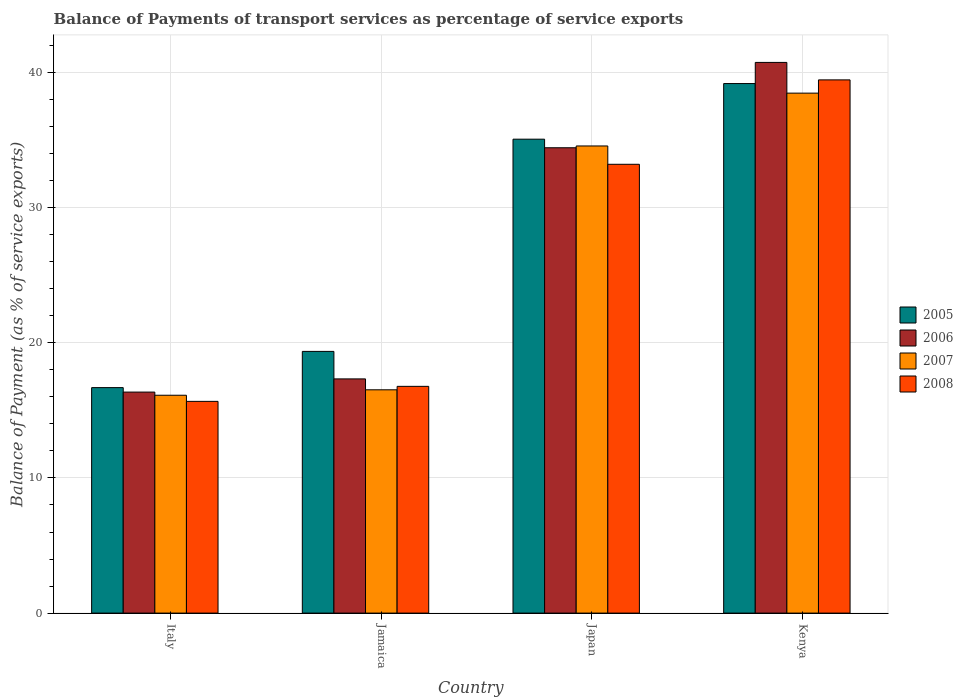How many different coloured bars are there?
Give a very brief answer. 4. Are the number of bars per tick equal to the number of legend labels?
Give a very brief answer. Yes. Are the number of bars on each tick of the X-axis equal?
Your answer should be compact. Yes. How many bars are there on the 2nd tick from the right?
Your answer should be compact. 4. What is the label of the 1st group of bars from the left?
Offer a very short reply. Italy. What is the balance of payments of transport services in 2008 in Kenya?
Provide a succinct answer. 39.45. Across all countries, what is the maximum balance of payments of transport services in 2006?
Offer a terse response. 40.74. Across all countries, what is the minimum balance of payments of transport services in 2006?
Offer a terse response. 16.35. In which country was the balance of payments of transport services in 2007 maximum?
Keep it short and to the point. Kenya. What is the total balance of payments of transport services in 2008 in the graph?
Give a very brief answer. 105.1. What is the difference between the balance of payments of transport services in 2005 in Jamaica and that in Kenya?
Your answer should be very brief. -19.82. What is the difference between the balance of payments of transport services in 2008 in Japan and the balance of payments of transport services in 2006 in Kenya?
Give a very brief answer. -7.54. What is the average balance of payments of transport services in 2005 per country?
Your response must be concise. 27.57. What is the difference between the balance of payments of transport services of/in 2006 and balance of payments of transport services of/in 2007 in Italy?
Offer a terse response. 0.23. What is the ratio of the balance of payments of transport services in 2006 in Italy to that in Jamaica?
Make the answer very short. 0.94. What is the difference between the highest and the second highest balance of payments of transport services in 2005?
Give a very brief answer. -15.7. What is the difference between the highest and the lowest balance of payments of transport services in 2005?
Your answer should be very brief. 22.5. In how many countries, is the balance of payments of transport services in 2008 greater than the average balance of payments of transport services in 2008 taken over all countries?
Keep it short and to the point. 2. Is the sum of the balance of payments of transport services in 2006 in Italy and Jamaica greater than the maximum balance of payments of transport services in 2007 across all countries?
Your response must be concise. No. What does the 4th bar from the right in Jamaica represents?
Make the answer very short. 2005. How many bars are there?
Make the answer very short. 16. Does the graph contain any zero values?
Offer a terse response. No. Does the graph contain grids?
Your response must be concise. Yes. Where does the legend appear in the graph?
Give a very brief answer. Center right. How many legend labels are there?
Make the answer very short. 4. What is the title of the graph?
Offer a very short reply. Balance of Payments of transport services as percentage of service exports. What is the label or title of the Y-axis?
Your answer should be very brief. Balance of Payment (as % of service exports). What is the Balance of Payment (as % of service exports) in 2005 in Italy?
Provide a short and direct response. 16.68. What is the Balance of Payment (as % of service exports) in 2006 in Italy?
Your answer should be compact. 16.35. What is the Balance of Payment (as % of service exports) of 2007 in Italy?
Your answer should be compact. 16.12. What is the Balance of Payment (as % of service exports) in 2008 in Italy?
Provide a succinct answer. 15.67. What is the Balance of Payment (as % of service exports) of 2005 in Jamaica?
Ensure brevity in your answer.  19.36. What is the Balance of Payment (as % of service exports) of 2006 in Jamaica?
Provide a succinct answer. 17.33. What is the Balance of Payment (as % of service exports) of 2007 in Jamaica?
Ensure brevity in your answer.  16.52. What is the Balance of Payment (as % of service exports) of 2008 in Jamaica?
Your response must be concise. 16.78. What is the Balance of Payment (as % of service exports) in 2005 in Japan?
Ensure brevity in your answer.  35.06. What is the Balance of Payment (as % of service exports) of 2006 in Japan?
Make the answer very short. 34.43. What is the Balance of Payment (as % of service exports) in 2007 in Japan?
Provide a short and direct response. 34.56. What is the Balance of Payment (as % of service exports) in 2008 in Japan?
Provide a short and direct response. 33.21. What is the Balance of Payment (as % of service exports) in 2005 in Kenya?
Offer a terse response. 39.18. What is the Balance of Payment (as % of service exports) of 2006 in Kenya?
Your answer should be very brief. 40.74. What is the Balance of Payment (as % of service exports) in 2007 in Kenya?
Provide a short and direct response. 38.47. What is the Balance of Payment (as % of service exports) of 2008 in Kenya?
Make the answer very short. 39.45. Across all countries, what is the maximum Balance of Payment (as % of service exports) of 2005?
Your response must be concise. 39.18. Across all countries, what is the maximum Balance of Payment (as % of service exports) of 2006?
Give a very brief answer. 40.74. Across all countries, what is the maximum Balance of Payment (as % of service exports) of 2007?
Provide a succinct answer. 38.47. Across all countries, what is the maximum Balance of Payment (as % of service exports) of 2008?
Give a very brief answer. 39.45. Across all countries, what is the minimum Balance of Payment (as % of service exports) in 2005?
Ensure brevity in your answer.  16.68. Across all countries, what is the minimum Balance of Payment (as % of service exports) in 2006?
Keep it short and to the point. 16.35. Across all countries, what is the minimum Balance of Payment (as % of service exports) of 2007?
Provide a short and direct response. 16.12. Across all countries, what is the minimum Balance of Payment (as % of service exports) of 2008?
Your answer should be very brief. 15.67. What is the total Balance of Payment (as % of service exports) of 2005 in the graph?
Ensure brevity in your answer.  110.29. What is the total Balance of Payment (as % of service exports) of 2006 in the graph?
Ensure brevity in your answer.  108.85. What is the total Balance of Payment (as % of service exports) in 2007 in the graph?
Keep it short and to the point. 105.67. What is the total Balance of Payment (as % of service exports) in 2008 in the graph?
Keep it short and to the point. 105.1. What is the difference between the Balance of Payment (as % of service exports) in 2005 in Italy and that in Jamaica?
Your answer should be compact. -2.68. What is the difference between the Balance of Payment (as % of service exports) in 2006 in Italy and that in Jamaica?
Your answer should be very brief. -0.98. What is the difference between the Balance of Payment (as % of service exports) of 2007 in Italy and that in Jamaica?
Give a very brief answer. -0.4. What is the difference between the Balance of Payment (as % of service exports) of 2008 in Italy and that in Jamaica?
Provide a short and direct response. -1.11. What is the difference between the Balance of Payment (as % of service exports) of 2005 in Italy and that in Japan?
Your answer should be compact. -18.38. What is the difference between the Balance of Payment (as % of service exports) in 2006 in Italy and that in Japan?
Offer a very short reply. -18.08. What is the difference between the Balance of Payment (as % of service exports) of 2007 in Italy and that in Japan?
Give a very brief answer. -18.44. What is the difference between the Balance of Payment (as % of service exports) of 2008 in Italy and that in Japan?
Your answer should be very brief. -17.54. What is the difference between the Balance of Payment (as % of service exports) in 2005 in Italy and that in Kenya?
Keep it short and to the point. -22.5. What is the difference between the Balance of Payment (as % of service exports) in 2006 in Italy and that in Kenya?
Keep it short and to the point. -24.39. What is the difference between the Balance of Payment (as % of service exports) of 2007 in Italy and that in Kenya?
Make the answer very short. -22.35. What is the difference between the Balance of Payment (as % of service exports) of 2008 in Italy and that in Kenya?
Your response must be concise. -23.79. What is the difference between the Balance of Payment (as % of service exports) of 2005 in Jamaica and that in Japan?
Make the answer very short. -15.7. What is the difference between the Balance of Payment (as % of service exports) of 2006 in Jamaica and that in Japan?
Your answer should be compact. -17.1. What is the difference between the Balance of Payment (as % of service exports) of 2007 in Jamaica and that in Japan?
Give a very brief answer. -18.04. What is the difference between the Balance of Payment (as % of service exports) in 2008 in Jamaica and that in Japan?
Your answer should be compact. -16.43. What is the difference between the Balance of Payment (as % of service exports) in 2005 in Jamaica and that in Kenya?
Ensure brevity in your answer.  -19.82. What is the difference between the Balance of Payment (as % of service exports) in 2006 in Jamaica and that in Kenya?
Make the answer very short. -23.42. What is the difference between the Balance of Payment (as % of service exports) in 2007 in Jamaica and that in Kenya?
Offer a very short reply. -21.95. What is the difference between the Balance of Payment (as % of service exports) of 2008 in Jamaica and that in Kenya?
Keep it short and to the point. -22.67. What is the difference between the Balance of Payment (as % of service exports) of 2005 in Japan and that in Kenya?
Your answer should be compact. -4.12. What is the difference between the Balance of Payment (as % of service exports) of 2006 in Japan and that in Kenya?
Ensure brevity in your answer.  -6.31. What is the difference between the Balance of Payment (as % of service exports) of 2007 in Japan and that in Kenya?
Provide a succinct answer. -3.91. What is the difference between the Balance of Payment (as % of service exports) in 2008 in Japan and that in Kenya?
Make the answer very short. -6.24. What is the difference between the Balance of Payment (as % of service exports) in 2005 in Italy and the Balance of Payment (as % of service exports) in 2006 in Jamaica?
Offer a terse response. -0.65. What is the difference between the Balance of Payment (as % of service exports) in 2005 in Italy and the Balance of Payment (as % of service exports) in 2007 in Jamaica?
Ensure brevity in your answer.  0.16. What is the difference between the Balance of Payment (as % of service exports) of 2005 in Italy and the Balance of Payment (as % of service exports) of 2008 in Jamaica?
Provide a short and direct response. -0.09. What is the difference between the Balance of Payment (as % of service exports) in 2006 in Italy and the Balance of Payment (as % of service exports) in 2007 in Jamaica?
Your answer should be very brief. -0.17. What is the difference between the Balance of Payment (as % of service exports) of 2006 in Italy and the Balance of Payment (as % of service exports) of 2008 in Jamaica?
Give a very brief answer. -0.43. What is the difference between the Balance of Payment (as % of service exports) of 2007 in Italy and the Balance of Payment (as % of service exports) of 2008 in Jamaica?
Provide a succinct answer. -0.66. What is the difference between the Balance of Payment (as % of service exports) of 2005 in Italy and the Balance of Payment (as % of service exports) of 2006 in Japan?
Offer a very short reply. -17.75. What is the difference between the Balance of Payment (as % of service exports) of 2005 in Italy and the Balance of Payment (as % of service exports) of 2007 in Japan?
Keep it short and to the point. -17.88. What is the difference between the Balance of Payment (as % of service exports) of 2005 in Italy and the Balance of Payment (as % of service exports) of 2008 in Japan?
Make the answer very short. -16.52. What is the difference between the Balance of Payment (as % of service exports) of 2006 in Italy and the Balance of Payment (as % of service exports) of 2007 in Japan?
Give a very brief answer. -18.21. What is the difference between the Balance of Payment (as % of service exports) in 2006 in Italy and the Balance of Payment (as % of service exports) in 2008 in Japan?
Your answer should be very brief. -16.86. What is the difference between the Balance of Payment (as % of service exports) in 2007 in Italy and the Balance of Payment (as % of service exports) in 2008 in Japan?
Provide a succinct answer. -17.09. What is the difference between the Balance of Payment (as % of service exports) in 2005 in Italy and the Balance of Payment (as % of service exports) in 2006 in Kenya?
Your answer should be very brief. -24.06. What is the difference between the Balance of Payment (as % of service exports) of 2005 in Italy and the Balance of Payment (as % of service exports) of 2007 in Kenya?
Offer a terse response. -21.79. What is the difference between the Balance of Payment (as % of service exports) of 2005 in Italy and the Balance of Payment (as % of service exports) of 2008 in Kenya?
Your answer should be very brief. -22.77. What is the difference between the Balance of Payment (as % of service exports) in 2006 in Italy and the Balance of Payment (as % of service exports) in 2007 in Kenya?
Offer a terse response. -22.12. What is the difference between the Balance of Payment (as % of service exports) of 2006 in Italy and the Balance of Payment (as % of service exports) of 2008 in Kenya?
Keep it short and to the point. -23.1. What is the difference between the Balance of Payment (as % of service exports) in 2007 in Italy and the Balance of Payment (as % of service exports) in 2008 in Kenya?
Offer a very short reply. -23.33. What is the difference between the Balance of Payment (as % of service exports) in 2005 in Jamaica and the Balance of Payment (as % of service exports) in 2006 in Japan?
Provide a succinct answer. -15.07. What is the difference between the Balance of Payment (as % of service exports) in 2005 in Jamaica and the Balance of Payment (as % of service exports) in 2007 in Japan?
Keep it short and to the point. -15.2. What is the difference between the Balance of Payment (as % of service exports) of 2005 in Jamaica and the Balance of Payment (as % of service exports) of 2008 in Japan?
Your answer should be compact. -13.84. What is the difference between the Balance of Payment (as % of service exports) of 2006 in Jamaica and the Balance of Payment (as % of service exports) of 2007 in Japan?
Keep it short and to the point. -17.23. What is the difference between the Balance of Payment (as % of service exports) of 2006 in Jamaica and the Balance of Payment (as % of service exports) of 2008 in Japan?
Provide a succinct answer. -15.88. What is the difference between the Balance of Payment (as % of service exports) in 2007 in Jamaica and the Balance of Payment (as % of service exports) in 2008 in Japan?
Provide a short and direct response. -16.69. What is the difference between the Balance of Payment (as % of service exports) in 2005 in Jamaica and the Balance of Payment (as % of service exports) in 2006 in Kenya?
Give a very brief answer. -21.38. What is the difference between the Balance of Payment (as % of service exports) of 2005 in Jamaica and the Balance of Payment (as % of service exports) of 2007 in Kenya?
Provide a short and direct response. -19.11. What is the difference between the Balance of Payment (as % of service exports) in 2005 in Jamaica and the Balance of Payment (as % of service exports) in 2008 in Kenya?
Make the answer very short. -20.09. What is the difference between the Balance of Payment (as % of service exports) in 2006 in Jamaica and the Balance of Payment (as % of service exports) in 2007 in Kenya?
Your answer should be compact. -21.14. What is the difference between the Balance of Payment (as % of service exports) of 2006 in Jamaica and the Balance of Payment (as % of service exports) of 2008 in Kenya?
Provide a short and direct response. -22.12. What is the difference between the Balance of Payment (as % of service exports) in 2007 in Jamaica and the Balance of Payment (as % of service exports) in 2008 in Kenya?
Your answer should be compact. -22.93. What is the difference between the Balance of Payment (as % of service exports) in 2005 in Japan and the Balance of Payment (as % of service exports) in 2006 in Kenya?
Your answer should be very brief. -5.68. What is the difference between the Balance of Payment (as % of service exports) in 2005 in Japan and the Balance of Payment (as % of service exports) in 2007 in Kenya?
Ensure brevity in your answer.  -3.41. What is the difference between the Balance of Payment (as % of service exports) of 2005 in Japan and the Balance of Payment (as % of service exports) of 2008 in Kenya?
Provide a succinct answer. -4.39. What is the difference between the Balance of Payment (as % of service exports) of 2006 in Japan and the Balance of Payment (as % of service exports) of 2007 in Kenya?
Ensure brevity in your answer.  -4.04. What is the difference between the Balance of Payment (as % of service exports) of 2006 in Japan and the Balance of Payment (as % of service exports) of 2008 in Kenya?
Ensure brevity in your answer.  -5.02. What is the difference between the Balance of Payment (as % of service exports) of 2007 in Japan and the Balance of Payment (as % of service exports) of 2008 in Kenya?
Give a very brief answer. -4.89. What is the average Balance of Payment (as % of service exports) in 2005 per country?
Keep it short and to the point. 27.57. What is the average Balance of Payment (as % of service exports) of 2006 per country?
Your answer should be compact. 27.21. What is the average Balance of Payment (as % of service exports) in 2007 per country?
Offer a very short reply. 26.42. What is the average Balance of Payment (as % of service exports) in 2008 per country?
Make the answer very short. 26.28. What is the difference between the Balance of Payment (as % of service exports) in 2005 and Balance of Payment (as % of service exports) in 2006 in Italy?
Provide a short and direct response. 0.33. What is the difference between the Balance of Payment (as % of service exports) in 2005 and Balance of Payment (as % of service exports) in 2007 in Italy?
Ensure brevity in your answer.  0.56. What is the difference between the Balance of Payment (as % of service exports) of 2005 and Balance of Payment (as % of service exports) of 2008 in Italy?
Provide a succinct answer. 1.02. What is the difference between the Balance of Payment (as % of service exports) of 2006 and Balance of Payment (as % of service exports) of 2007 in Italy?
Give a very brief answer. 0.23. What is the difference between the Balance of Payment (as % of service exports) of 2006 and Balance of Payment (as % of service exports) of 2008 in Italy?
Offer a very short reply. 0.69. What is the difference between the Balance of Payment (as % of service exports) in 2007 and Balance of Payment (as % of service exports) in 2008 in Italy?
Your answer should be compact. 0.45. What is the difference between the Balance of Payment (as % of service exports) of 2005 and Balance of Payment (as % of service exports) of 2006 in Jamaica?
Make the answer very short. 2.03. What is the difference between the Balance of Payment (as % of service exports) of 2005 and Balance of Payment (as % of service exports) of 2007 in Jamaica?
Make the answer very short. 2.84. What is the difference between the Balance of Payment (as % of service exports) in 2005 and Balance of Payment (as % of service exports) in 2008 in Jamaica?
Your response must be concise. 2.59. What is the difference between the Balance of Payment (as % of service exports) of 2006 and Balance of Payment (as % of service exports) of 2007 in Jamaica?
Make the answer very short. 0.81. What is the difference between the Balance of Payment (as % of service exports) of 2006 and Balance of Payment (as % of service exports) of 2008 in Jamaica?
Your answer should be very brief. 0.55. What is the difference between the Balance of Payment (as % of service exports) in 2007 and Balance of Payment (as % of service exports) in 2008 in Jamaica?
Provide a succinct answer. -0.26. What is the difference between the Balance of Payment (as % of service exports) of 2005 and Balance of Payment (as % of service exports) of 2006 in Japan?
Ensure brevity in your answer.  0.63. What is the difference between the Balance of Payment (as % of service exports) of 2005 and Balance of Payment (as % of service exports) of 2007 in Japan?
Offer a very short reply. 0.5. What is the difference between the Balance of Payment (as % of service exports) in 2005 and Balance of Payment (as % of service exports) in 2008 in Japan?
Offer a very short reply. 1.86. What is the difference between the Balance of Payment (as % of service exports) in 2006 and Balance of Payment (as % of service exports) in 2007 in Japan?
Ensure brevity in your answer.  -0.13. What is the difference between the Balance of Payment (as % of service exports) in 2006 and Balance of Payment (as % of service exports) in 2008 in Japan?
Keep it short and to the point. 1.22. What is the difference between the Balance of Payment (as % of service exports) in 2007 and Balance of Payment (as % of service exports) in 2008 in Japan?
Offer a terse response. 1.36. What is the difference between the Balance of Payment (as % of service exports) of 2005 and Balance of Payment (as % of service exports) of 2006 in Kenya?
Provide a short and direct response. -1.56. What is the difference between the Balance of Payment (as % of service exports) in 2005 and Balance of Payment (as % of service exports) in 2007 in Kenya?
Provide a short and direct response. 0.71. What is the difference between the Balance of Payment (as % of service exports) in 2005 and Balance of Payment (as % of service exports) in 2008 in Kenya?
Provide a short and direct response. -0.27. What is the difference between the Balance of Payment (as % of service exports) in 2006 and Balance of Payment (as % of service exports) in 2007 in Kenya?
Your answer should be compact. 2.27. What is the difference between the Balance of Payment (as % of service exports) in 2006 and Balance of Payment (as % of service exports) in 2008 in Kenya?
Make the answer very short. 1.29. What is the difference between the Balance of Payment (as % of service exports) in 2007 and Balance of Payment (as % of service exports) in 2008 in Kenya?
Provide a succinct answer. -0.98. What is the ratio of the Balance of Payment (as % of service exports) of 2005 in Italy to that in Jamaica?
Ensure brevity in your answer.  0.86. What is the ratio of the Balance of Payment (as % of service exports) of 2006 in Italy to that in Jamaica?
Your response must be concise. 0.94. What is the ratio of the Balance of Payment (as % of service exports) in 2007 in Italy to that in Jamaica?
Provide a succinct answer. 0.98. What is the ratio of the Balance of Payment (as % of service exports) of 2008 in Italy to that in Jamaica?
Your answer should be compact. 0.93. What is the ratio of the Balance of Payment (as % of service exports) of 2005 in Italy to that in Japan?
Provide a succinct answer. 0.48. What is the ratio of the Balance of Payment (as % of service exports) of 2006 in Italy to that in Japan?
Offer a very short reply. 0.47. What is the ratio of the Balance of Payment (as % of service exports) of 2007 in Italy to that in Japan?
Keep it short and to the point. 0.47. What is the ratio of the Balance of Payment (as % of service exports) of 2008 in Italy to that in Japan?
Provide a succinct answer. 0.47. What is the ratio of the Balance of Payment (as % of service exports) in 2005 in Italy to that in Kenya?
Offer a very short reply. 0.43. What is the ratio of the Balance of Payment (as % of service exports) of 2006 in Italy to that in Kenya?
Offer a very short reply. 0.4. What is the ratio of the Balance of Payment (as % of service exports) of 2007 in Italy to that in Kenya?
Your answer should be compact. 0.42. What is the ratio of the Balance of Payment (as % of service exports) of 2008 in Italy to that in Kenya?
Provide a short and direct response. 0.4. What is the ratio of the Balance of Payment (as % of service exports) in 2005 in Jamaica to that in Japan?
Provide a short and direct response. 0.55. What is the ratio of the Balance of Payment (as % of service exports) of 2006 in Jamaica to that in Japan?
Your response must be concise. 0.5. What is the ratio of the Balance of Payment (as % of service exports) of 2007 in Jamaica to that in Japan?
Your answer should be very brief. 0.48. What is the ratio of the Balance of Payment (as % of service exports) of 2008 in Jamaica to that in Japan?
Your answer should be very brief. 0.51. What is the ratio of the Balance of Payment (as % of service exports) of 2005 in Jamaica to that in Kenya?
Your answer should be compact. 0.49. What is the ratio of the Balance of Payment (as % of service exports) of 2006 in Jamaica to that in Kenya?
Provide a succinct answer. 0.43. What is the ratio of the Balance of Payment (as % of service exports) in 2007 in Jamaica to that in Kenya?
Give a very brief answer. 0.43. What is the ratio of the Balance of Payment (as % of service exports) of 2008 in Jamaica to that in Kenya?
Give a very brief answer. 0.43. What is the ratio of the Balance of Payment (as % of service exports) in 2005 in Japan to that in Kenya?
Provide a short and direct response. 0.9. What is the ratio of the Balance of Payment (as % of service exports) in 2006 in Japan to that in Kenya?
Offer a very short reply. 0.84. What is the ratio of the Balance of Payment (as % of service exports) in 2007 in Japan to that in Kenya?
Your answer should be compact. 0.9. What is the ratio of the Balance of Payment (as % of service exports) in 2008 in Japan to that in Kenya?
Offer a terse response. 0.84. What is the difference between the highest and the second highest Balance of Payment (as % of service exports) of 2005?
Your response must be concise. 4.12. What is the difference between the highest and the second highest Balance of Payment (as % of service exports) in 2006?
Keep it short and to the point. 6.31. What is the difference between the highest and the second highest Balance of Payment (as % of service exports) in 2007?
Give a very brief answer. 3.91. What is the difference between the highest and the second highest Balance of Payment (as % of service exports) in 2008?
Provide a succinct answer. 6.24. What is the difference between the highest and the lowest Balance of Payment (as % of service exports) in 2005?
Ensure brevity in your answer.  22.5. What is the difference between the highest and the lowest Balance of Payment (as % of service exports) of 2006?
Your answer should be very brief. 24.39. What is the difference between the highest and the lowest Balance of Payment (as % of service exports) in 2007?
Offer a very short reply. 22.35. What is the difference between the highest and the lowest Balance of Payment (as % of service exports) in 2008?
Your answer should be compact. 23.79. 